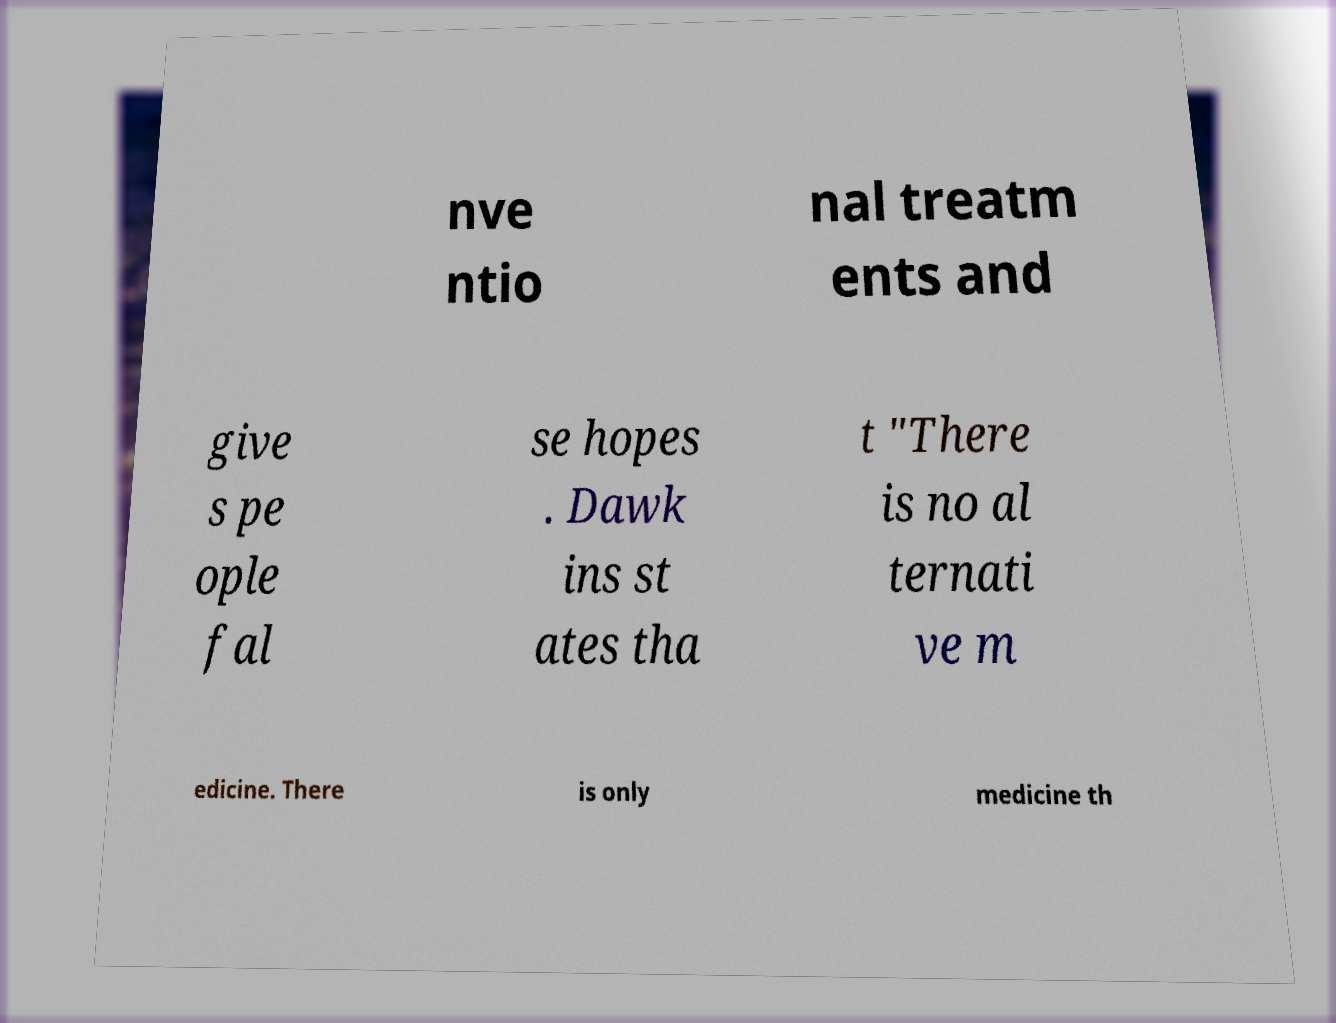Can you read and provide the text displayed in the image?This photo seems to have some interesting text. Can you extract and type it out for me? nve ntio nal treatm ents and give s pe ople fal se hopes . Dawk ins st ates tha t "There is no al ternati ve m edicine. There is only medicine th 